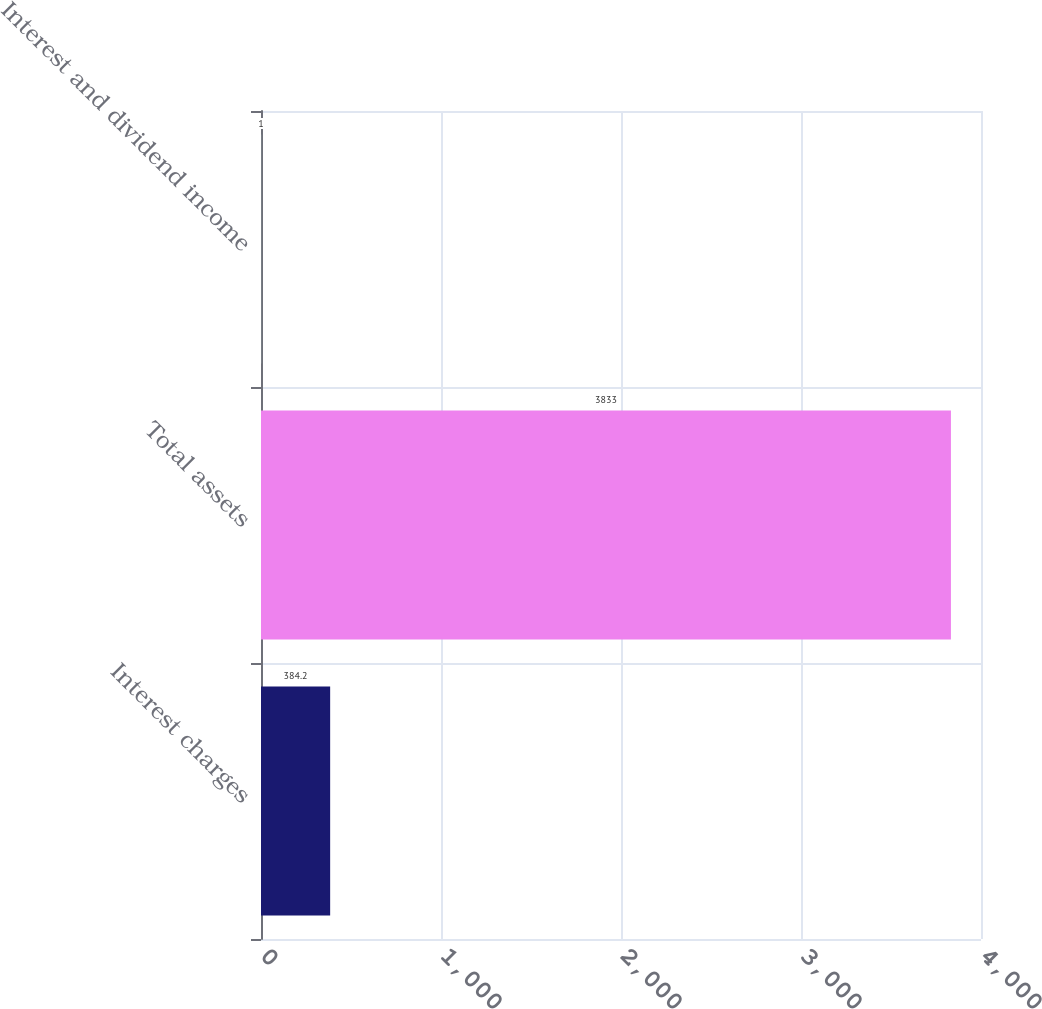<chart> <loc_0><loc_0><loc_500><loc_500><bar_chart><fcel>Interest charges<fcel>Total assets<fcel>Interest and dividend income<nl><fcel>384.2<fcel>3833<fcel>1<nl></chart> 